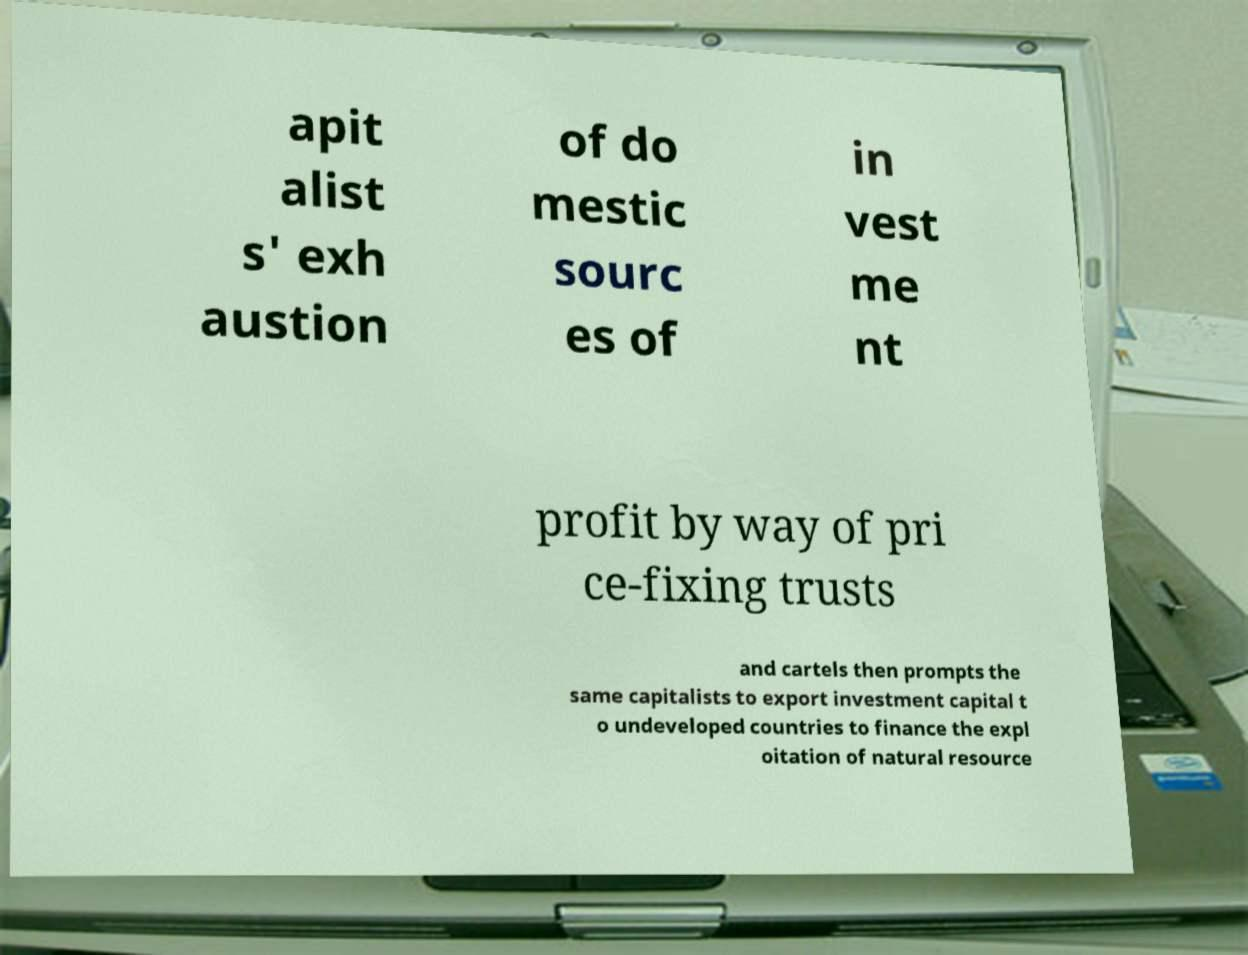Please identify and transcribe the text found in this image. apit alist s' exh austion of do mestic sourc es of in vest me nt profit by way of pri ce-fixing trusts and cartels then prompts the same capitalists to export investment capital t o undeveloped countries to finance the expl oitation of natural resource 